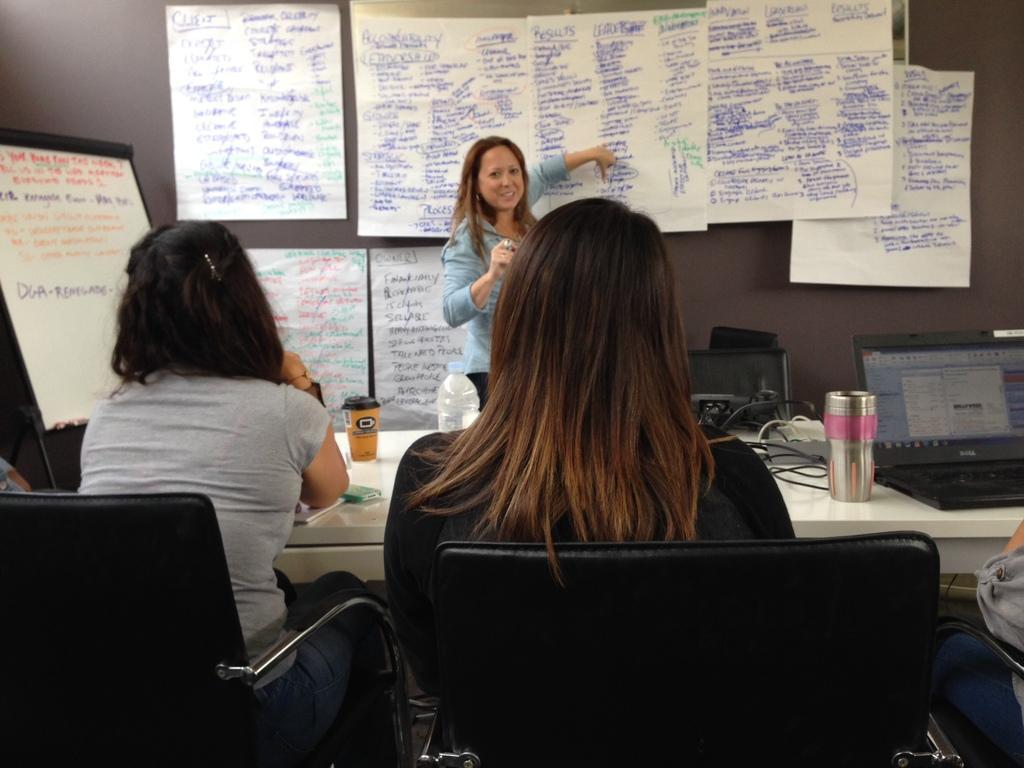Could you give a brief overview of what you see in this image? In this picture I can see 2 women and a person sitting on chairs in front and in front of them I can see a table, on which there is a bottle, a cup, a laptop, few wires and other things. In the background I can see a woman standing and I can see the wall on which there are number of papers and I see something is written. I can also see a board on the left side of this image and I see something is written on it. 